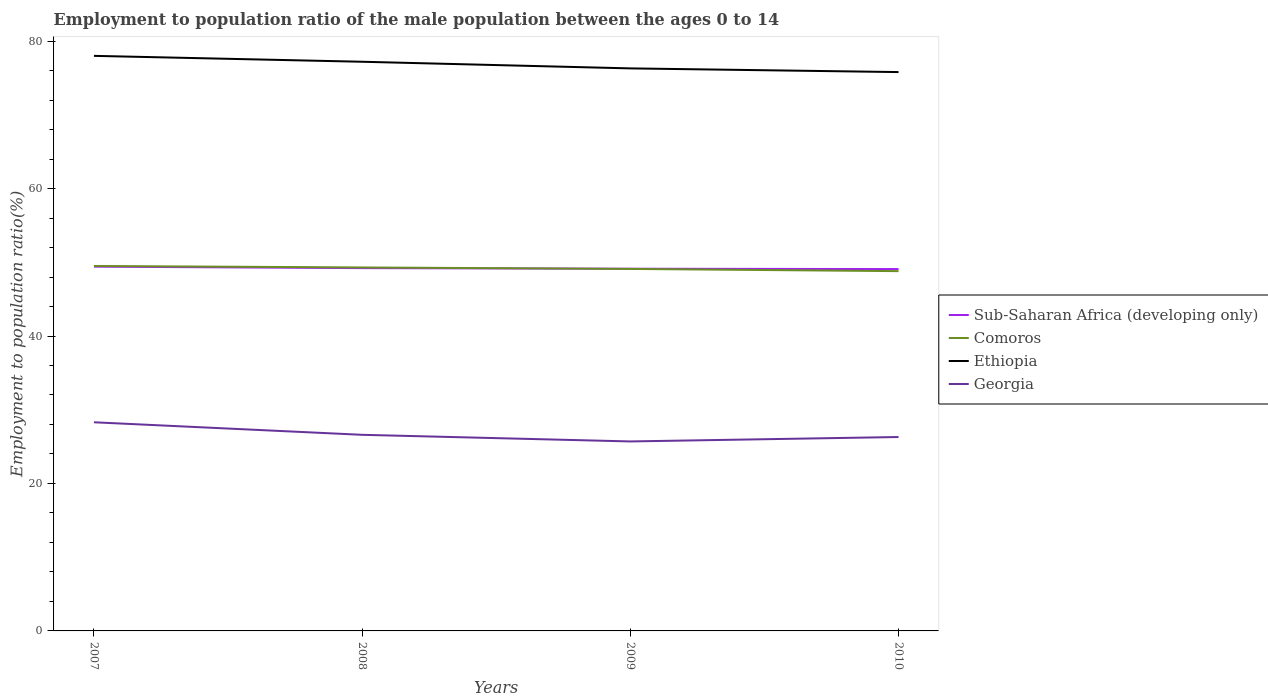How many different coloured lines are there?
Offer a very short reply. 4. Across all years, what is the maximum employment to population ratio in Georgia?
Keep it short and to the point. 25.7. What is the total employment to population ratio in Georgia in the graph?
Your answer should be very brief. 2.6. What is the difference between the highest and the second highest employment to population ratio in Sub-Saharan Africa (developing only)?
Your answer should be compact. 0.33. How many years are there in the graph?
Make the answer very short. 4. Does the graph contain any zero values?
Provide a succinct answer. No. Where does the legend appear in the graph?
Give a very brief answer. Center right. How many legend labels are there?
Your answer should be compact. 4. What is the title of the graph?
Your answer should be very brief. Employment to population ratio of the male population between the ages 0 to 14. What is the label or title of the Y-axis?
Make the answer very short. Employment to population ratio(%). What is the Employment to population ratio(%) of Sub-Saharan Africa (developing only) in 2007?
Your response must be concise. 49.41. What is the Employment to population ratio(%) of Comoros in 2007?
Provide a short and direct response. 49.5. What is the Employment to population ratio(%) of Georgia in 2007?
Give a very brief answer. 28.3. What is the Employment to population ratio(%) in Sub-Saharan Africa (developing only) in 2008?
Your answer should be very brief. 49.21. What is the Employment to population ratio(%) in Comoros in 2008?
Make the answer very short. 49.3. What is the Employment to population ratio(%) of Ethiopia in 2008?
Your answer should be very brief. 77.2. What is the Employment to population ratio(%) in Georgia in 2008?
Make the answer very short. 26.6. What is the Employment to population ratio(%) of Sub-Saharan Africa (developing only) in 2009?
Give a very brief answer. 49.13. What is the Employment to population ratio(%) of Comoros in 2009?
Your answer should be very brief. 49.1. What is the Employment to population ratio(%) in Ethiopia in 2009?
Give a very brief answer. 76.3. What is the Employment to population ratio(%) in Georgia in 2009?
Your response must be concise. 25.7. What is the Employment to population ratio(%) of Sub-Saharan Africa (developing only) in 2010?
Keep it short and to the point. 49.08. What is the Employment to population ratio(%) of Comoros in 2010?
Your answer should be compact. 48.8. What is the Employment to population ratio(%) of Ethiopia in 2010?
Ensure brevity in your answer.  75.8. What is the Employment to population ratio(%) in Georgia in 2010?
Give a very brief answer. 26.3. Across all years, what is the maximum Employment to population ratio(%) of Sub-Saharan Africa (developing only)?
Provide a short and direct response. 49.41. Across all years, what is the maximum Employment to population ratio(%) in Comoros?
Give a very brief answer. 49.5. Across all years, what is the maximum Employment to population ratio(%) in Georgia?
Ensure brevity in your answer.  28.3. Across all years, what is the minimum Employment to population ratio(%) of Sub-Saharan Africa (developing only)?
Ensure brevity in your answer.  49.08. Across all years, what is the minimum Employment to population ratio(%) in Comoros?
Offer a very short reply. 48.8. Across all years, what is the minimum Employment to population ratio(%) in Ethiopia?
Your response must be concise. 75.8. Across all years, what is the minimum Employment to population ratio(%) in Georgia?
Ensure brevity in your answer.  25.7. What is the total Employment to population ratio(%) of Sub-Saharan Africa (developing only) in the graph?
Ensure brevity in your answer.  196.82. What is the total Employment to population ratio(%) in Comoros in the graph?
Give a very brief answer. 196.7. What is the total Employment to population ratio(%) in Ethiopia in the graph?
Give a very brief answer. 307.3. What is the total Employment to population ratio(%) of Georgia in the graph?
Ensure brevity in your answer.  106.9. What is the difference between the Employment to population ratio(%) in Sub-Saharan Africa (developing only) in 2007 and that in 2008?
Your response must be concise. 0.2. What is the difference between the Employment to population ratio(%) in Ethiopia in 2007 and that in 2008?
Make the answer very short. 0.8. What is the difference between the Employment to population ratio(%) of Georgia in 2007 and that in 2008?
Your answer should be very brief. 1.7. What is the difference between the Employment to population ratio(%) in Sub-Saharan Africa (developing only) in 2007 and that in 2009?
Your answer should be very brief. 0.28. What is the difference between the Employment to population ratio(%) in Sub-Saharan Africa (developing only) in 2007 and that in 2010?
Offer a very short reply. 0.33. What is the difference between the Employment to population ratio(%) of Comoros in 2007 and that in 2010?
Make the answer very short. 0.7. What is the difference between the Employment to population ratio(%) of Sub-Saharan Africa (developing only) in 2008 and that in 2009?
Keep it short and to the point. 0.08. What is the difference between the Employment to population ratio(%) of Comoros in 2008 and that in 2009?
Provide a short and direct response. 0.2. What is the difference between the Employment to population ratio(%) of Sub-Saharan Africa (developing only) in 2008 and that in 2010?
Offer a very short reply. 0.13. What is the difference between the Employment to population ratio(%) of Comoros in 2008 and that in 2010?
Make the answer very short. 0.5. What is the difference between the Employment to population ratio(%) in Georgia in 2008 and that in 2010?
Ensure brevity in your answer.  0.3. What is the difference between the Employment to population ratio(%) in Sub-Saharan Africa (developing only) in 2009 and that in 2010?
Keep it short and to the point. 0.05. What is the difference between the Employment to population ratio(%) of Comoros in 2009 and that in 2010?
Your answer should be compact. 0.3. What is the difference between the Employment to population ratio(%) in Ethiopia in 2009 and that in 2010?
Make the answer very short. 0.5. What is the difference between the Employment to population ratio(%) in Sub-Saharan Africa (developing only) in 2007 and the Employment to population ratio(%) in Comoros in 2008?
Provide a succinct answer. 0.11. What is the difference between the Employment to population ratio(%) in Sub-Saharan Africa (developing only) in 2007 and the Employment to population ratio(%) in Ethiopia in 2008?
Offer a terse response. -27.79. What is the difference between the Employment to population ratio(%) in Sub-Saharan Africa (developing only) in 2007 and the Employment to population ratio(%) in Georgia in 2008?
Give a very brief answer. 22.81. What is the difference between the Employment to population ratio(%) of Comoros in 2007 and the Employment to population ratio(%) of Ethiopia in 2008?
Provide a succinct answer. -27.7. What is the difference between the Employment to population ratio(%) in Comoros in 2007 and the Employment to population ratio(%) in Georgia in 2008?
Your response must be concise. 22.9. What is the difference between the Employment to population ratio(%) in Ethiopia in 2007 and the Employment to population ratio(%) in Georgia in 2008?
Your answer should be compact. 51.4. What is the difference between the Employment to population ratio(%) of Sub-Saharan Africa (developing only) in 2007 and the Employment to population ratio(%) of Comoros in 2009?
Provide a short and direct response. 0.31. What is the difference between the Employment to population ratio(%) of Sub-Saharan Africa (developing only) in 2007 and the Employment to population ratio(%) of Ethiopia in 2009?
Keep it short and to the point. -26.89. What is the difference between the Employment to population ratio(%) of Sub-Saharan Africa (developing only) in 2007 and the Employment to population ratio(%) of Georgia in 2009?
Offer a very short reply. 23.71. What is the difference between the Employment to population ratio(%) of Comoros in 2007 and the Employment to population ratio(%) of Ethiopia in 2009?
Make the answer very short. -26.8. What is the difference between the Employment to population ratio(%) of Comoros in 2007 and the Employment to population ratio(%) of Georgia in 2009?
Make the answer very short. 23.8. What is the difference between the Employment to population ratio(%) in Ethiopia in 2007 and the Employment to population ratio(%) in Georgia in 2009?
Your answer should be compact. 52.3. What is the difference between the Employment to population ratio(%) in Sub-Saharan Africa (developing only) in 2007 and the Employment to population ratio(%) in Comoros in 2010?
Provide a short and direct response. 0.61. What is the difference between the Employment to population ratio(%) in Sub-Saharan Africa (developing only) in 2007 and the Employment to population ratio(%) in Ethiopia in 2010?
Provide a short and direct response. -26.39. What is the difference between the Employment to population ratio(%) of Sub-Saharan Africa (developing only) in 2007 and the Employment to population ratio(%) of Georgia in 2010?
Your response must be concise. 23.11. What is the difference between the Employment to population ratio(%) of Comoros in 2007 and the Employment to population ratio(%) of Ethiopia in 2010?
Offer a very short reply. -26.3. What is the difference between the Employment to population ratio(%) in Comoros in 2007 and the Employment to population ratio(%) in Georgia in 2010?
Keep it short and to the point. 23.2. What is the difference between the Employment to population ratio(%) of Ethiopia in 2007 and the Employment to population ratio(%) of Georgia in 2010?
Make the answer very short. 51.7. What is the difference between the Employment to population ratio(%) in Sub-Saharan Africa (developing only) in 2008 and the Employment to population ratio(%) in Comoros in 2009?
Ensure brevity in your answer.  0.11. What is the difference between the Employment to population ratio(%) of Sub-Saharan Africa (developing only) in 2008 and the Employment to population ratio(%) of Ethiopia in 2009?
Your answer should be very brief. -27.09. What is the difference between the Employment to population ratio(%) of Sub-Saharan Africa (developing only) in 2008 and the Employment to population ratio(%) of Georgia in 2009?
Make the answer very short. 23.51. What is the difference between the Employment to population ratio(%) in Comoros in 2008 and the Employment to population ratio(%) in Georgia in 2009?
Your answer should be very brief. 23.6. What is the difference between the Employment to population ratio(%) of Ethiopia in 2008 and the Employment to population ratio(%) of Georgia in 2009?
Ensure brevity in your answer.  51.5. What is the difference between the Employment to population ratio(%) of Sub-Saharan Africa (developing only) in 2008 and the Employment to population ratio(%) of Comoros in 2010?
Ensure brevity in your answer.  0.41. What is the difference between the Employment to population ratio(%) of Sub-Saharan Africa (developing only) in 2008 and the Employment to population ratio(%) of Ethiopia in 2010?
Ensure brevity in your answer.  -26.59. What is the difference between the Employment to population ratio(%) in Sub-Saharan Africa (developing only) in 2008 and the Employment to population ratio(%) in Georgia in 2010?
Your response must be concise. 22.91. What is the difference between the Employment to population ratio(%) of Comoros in 2008 and the Employment to population ratio(%) of Ethiopia in 2010?
Provide a succinct answer. -26.5. What is the difference between the Employment to population ratio(%) in Comoros in 2008 and the Employment to population ratio(%) in Georgia in 2010?
Your response must be concise. 23. What is the difference between the Employment to population ratio(%) of Ethiopia in 2008 and the Employment to population ratio(%) of Georgia in 2010?
Your answer should be compact. 50.9. What is the difference between the Employment to population ratio(%) in Sub-Saharan Africa (developing only) in 2009 and the Employment to population ratio(%) in Comoros in 2010?
Your answer should be compact. 0.33. What is the difference between the Employment to population ratio(%) in Sub-Saharan Africa (developing only) in 2009 and the Employment to population ratio(%) in Ethiopia in 2010?
Offer a terse response. -26.67. What is the difference between the Employment to population ratio(%) in Sub-Saharan Africa (developing only) in 2009 and the Employment to population ratio(%) in Georgia in 2010?
Your response must be concise. 22.83. What is the difference between the Employment to population ratio(%) in Comoros in 2009 and the Employment to population ratio(%) in Ethiopia in 2010?
Your response must be concise. -26.7. What is the difference between the Employment to population ratio(%) in Comoros in 2009 and the Employment to population ratio(%) in Georgia in 2010?
Offer a very short reply. 22.8. What is the average Employment to population ratio(%) of Sub-Saharan Africa (developing only) per year?
Give a very brief answer. 49.21. What is the average Employment to population ratio(%) in Comoros per year?
Your response must be concise. 49.17. What is the average Employment to population ratio(%) in Ethiopia per year?
Give a very brief answer. 76.83. What is the average Employment to population ratio(%) in Georgia per year?
Ensure brevity in your answer.  26.73. In the year 2007, what is the difference between the Employment to population ratio(%) of Sub-Saharan Africa (developing only) and Employment to population ratio(%) of Comoros?
Give a very brief answer. -0.09. In the year 2007, what is the difference between the Employment to population ratio(%) in Sub-Saharan Africa (developing only) and Employment to population ratio(%) in Ethiopia?
Offer a terse response. -28.59. In the year 2007, what is the difference between the Employment to population ratio(%) in Sub-Saharan Africa (developing only) and Employment to population ratio(%) in Georgia?
Make the answer very short. 21.11. In the year 2007, what is the difference between the Employment to population ratio(%) of Comoros and Employment to population ratio(%) of Ethiopia?
Make the answer very short. -28.5. In the year 2007, what is the difference between the Employment to population ratio(%) of Comoros and Employment to population ratio(%) of Georgia?
Keep it short and to the point. 21.2. In the year 2007, what is the difference between the Employment to population ratio(%) in Ethiopia and Employment to population ratio(%) in Georgia?
Your answer should be very brief. 49.7. In the year 2008, what is the difference between the Employment to population ratio(%) of Sub-Saharan Africa (developing only) and Employment to population ratio(%) of Comoros?
Your response must be concise. -0.09. In the year 2008, what is the difference between the Employment to population ratio(%) of Sub-Saharan Africa (developing only) and Employment to population ratio(%) of Ethiopia?
Offer a very short reply. -27.99. In the year 2008, what is the difference between the Employment to population ratio(%) of Sub-Saharan Africa (developing only) and Employment to population ratio(%) of Georgia?
Give a very brief answer. 22.61. In the year 2008, what is the difference between the Employment to population ratio(%) in Comoros and Employment to population ratio(%) in Ethiopia?
Make the answer very short. -27.9. In the year 2008, what is the difference between the Employment to population ratio(%) of Comoros and Employment to population ratio(%) of Georgia?
Provide a succinct answer. 22.7. In the year 2008, what is the difference between the Employment to population ratio(%) of Ethiopia and Employment to population ratio(%) of Georgia?
Your answer should be very brief. 50.6. In the year 2009, what is the difference between the Employment to population ratio(%) of Sub-Saharan Africa (developing only) and Employment to population ratio(%) of Comoros?
Offer a terse response. 0.03. In the year 2009, what is the difference between the Employment to population ratio(%) of Sub-Saharan Africa (developing only) and Employment to population ratio(%) of Ethiopia?
Make the answer very short. -27.17. In the year 2009, what is the difference between the Employment to population ratio(%) in Sub-Saharan Africa (developing only) and Employment to population ratio(%) in Georgia?
Provide a succinct answer. 23.43. In the year 2009, what is the difference between the Employment to population ratio(%) of Comoros and Employment to population ratio(%) of Ethiopia?
Keep it short and to the point. -27.2. In the year 2009, what is the difference between the Employment to population ratio(%) in Comoros and Employment to population ratio(%) in Georgia?
Keep it short and to the point. 23.4. In the year 2009, what is the difference between the Employment to population ratio(%) in Ethiopia and Employment to population ratio(%) in Georgia?
Provide a succinct answer. 50.6. In the year 2010, what is the difference between the Employment to population ratio(%) of Sub-Saharan Africa (developing only) and Employment to population ratio(%) of Comoros?
Give a very brief answer. 0.28. In the year 2010, what is the difference between the Employment to population ratio(%) of Sub-Saharan Africa (developing only) and Employment to population ratio(%) of Ethiopia?
Keep it short and to the point. -26.72. In the year 2010, what is the difference between the Employment to population ratio(%) in Sub-Saharan Africa (developing only) and Employment to population ratio(%) in Georgia?
Offer a terse response. 22.78. In the year 2010, what is the difference between the Employment to population ratio(%) in Comoros and Employment to population ratio(%) in Ethiopia?
Offer a terse response. -27. In the year 2010, what is the difference between the Employment to population ratio(%) in Ethiopia and Employment to population ratio(%) in Georgia?
Provide a short and direct response. 49.5. What is the ratio of the Employment to population ratio(%) of Sub-Saharan Africa (developing only) in 2007 to that in 2008?
Offer a terse response. 1. What is the ratio of the Employment to population ratio(%) in Ethiopia in 2007 to that in 2008?
Your response must be concise. 1.01. What is the ratio of the Employment to population ratio(%) of Georgia in 2007 to that in 2008?
Your answer should be compact. 1.06. What is the ratio of the Employment to population ratio(%) of Sub-Saharan Africa (developing only) in 2007 to that in 2009?
Keep it short and to the point. 1.01. What is the ratio of the Employment to population ratio(%) of Comoros in 2007 to that in 2009?
Keep it short and to the point. 1.01. What is the ratio of the Employment to population ratio(%) in Ethiopia in 2007 to that in 2009?
Ensure brevity in your answer.  1.02. What is the ratio of the Employment to population ratio(%) of Georgia in 2007 to that in 2009?
Offer a terse response. 1.1. What is the ratio of the Employment to population ratio(%) of Sub-Saharan Africa (developing only) in 2007 to that in 2010?
Provide a short and direct response. 1.01. What is the ratio of the Employment to population ratio(%) of Comoros in 2007 to that in 2010?
Make the answer very short. 1.01. What is the ratio of the Employment to population ratio(%) in Ethiopia in 2007 to that in 2010?
Your answer should be compact. 1.03. What is the ratio of the Employment to population ratio(%) in Georgia in 2007 to that in 2010?
Keep it short and to the point. 1.08. What is the ratio of the Employment to population ratio(%) of Sub-Saharan Africa (developing only) in 2008 to that in 2009?
Ensure brevity in your answer.  1. What is the ratio of the Employment to population ratio(%) of Ethiopia in 2008 to that in 2009?
Provide a short and direct response. 1.01. What is the ratio of the Employment to population ratio(%) in Georgia in 2008 to that in 2009?
Your response must be concise. 1.03. What is the ratio of the Employment to population ratio(%) of Comoros in 2008 to that in 2010?
Your answer should be compact. 1.01. What is the ratio of the Employment to population ratio(%) of Ethiopia in 2008 to that in 2010?
Give a very brief answer. 1.02. What is the ratio of the Employment to population ratio(%) of Georgia in 2008 to that in 2010?
Offer a very short reply. 1.01. What is the ratio of the Employment to population ratio(%) of Ethiopia in 2009 to that in 2010?
Provide a short and direct response. 1.01. What is the ratio of the Employment to population ratio(%) in Georgia in 2009 to that in 2010?
Make the answer very short. 0.98. What is the difference between the highest and the second highest Employment to population ratio(%) of Sub-Saharan Africa (developing only)?
Offer a terse response. 0.2. What is the difference between the highest and the second highest Employment to population ratio(%) of Ethiopia?
Keep it short and to the point. 0.8. What is the difference between the highest and the lowest Employment to population ratio(%) of Sub-Saharan Africa (developing only)?
Make the answer very short. 0.33. What is the difference between the highest and the lowest Employment to population ratio(%) in Comoros?
Your answer should be very brief. 0.7. What is the difference between the highest and the lowest Employment to population ratio(%) of Ethiopia?
Provide a short and direct response. 2.2. What is the difference between the highest and the lowest Employment to population ratio(%) in Georgia?
Provide a short and direct response. 2.6. 